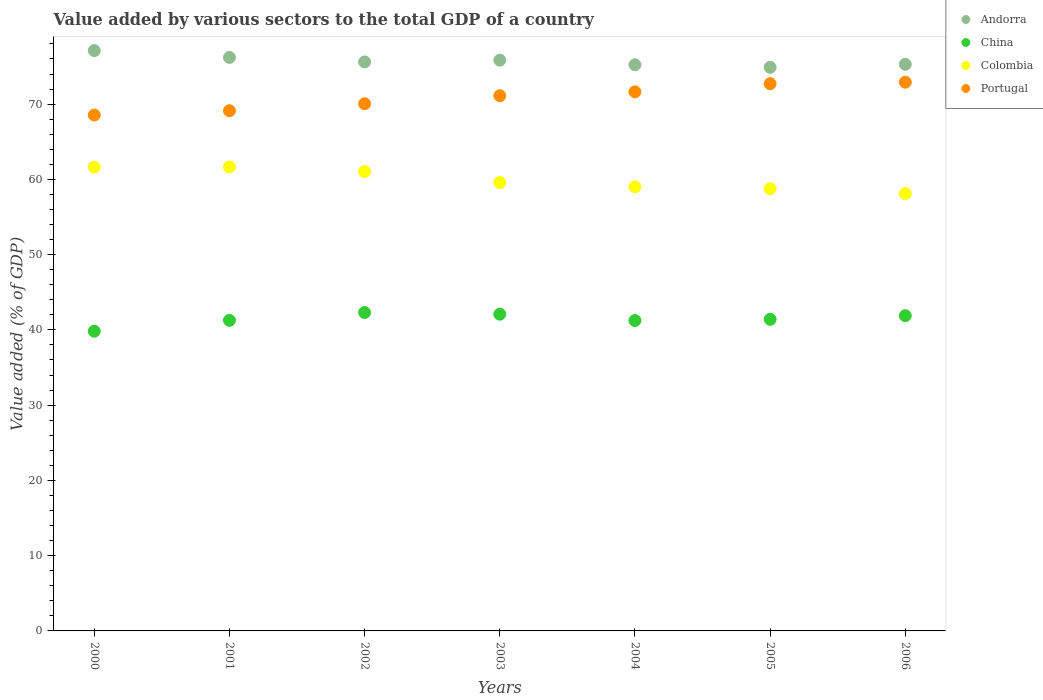Is the number of dotlines equal to the number of legend labels?
Give a very brief answer. Yes. What is the value added by various sectors to the total GDP in Portugal in 2001?
Give a very brief answer. 69.12. Across all years, what is the maximum value added by various sectors to the total GDP in Portugal?
Your answer should be very brief. 72.91. Across all years, what is the minimum value added by various sectors to the total GDP in Portugal?
Keep it short and to the point. 68.55. What is the total value added by various sectors to the total GDP in Portugal in the graph?
Provide a succinct answer. 496.09. What is the difference between the value added by various sectors to the total GDP in China in 2003 and that in 2006?
Ensure brevity in your answer.  0.2. What is the difference between the value added by various sectors to the total GDP in Colombia in 2003 and the value added by various sectors to the total GDP in Portugal in 2000?
Provide a succinct answer. -8.96. What is the average value added by various sectors to the total GDP in Portugal per year?
Make the answer very short. 70.87. In the year 2001, what is the difference between the value added by various sectors to the total GDP in Colombia and value added by various sectors to the total GDP in Andorra?
Make the answer very short. -14.54. What is the ratio of the value added by various sectors to the total GDP in Andorra in 2000 to that in 2005?
Offer a very short reply. 1.03. What is the difference between the highest and the second highest value added by various sectors to the total GDP in Andorra?
Provide a succinct answer. 0.91. What is the difference between the highest and the lowest value added by various sectors to the total GDP in Colombia?
Ensure brevity in your answer.  3.54. Is the sum of the value added by various sectors to the total GDP in Portugal in 2003 and 2004 greater than the maximum value added by various sectors to the total GDP in China across all years?
Provide a succinct answer. Yes. Is it the case that in every year, the sum of the value added by various sectors to the total GDP in Andorra and value added by various sectors to the total GDP in China  is greater than the value added by various sectors to the total GDP in Portugal?
Ensure brevity in your answer.  Yes. Does the value added by various sectors to the total GDP in Colombia monotonically increase over the years?
Provide a short and direct response. No. Are the values on the major ticks of Y-axis written in scientific E-notation?
Offer a very short reply. No. Does the graph contain grids?
Your answer should be compact. No. Where does the legend appear in the graph?
Ensure brevity in your answer.  Top right. What is the title of the graph?
Your answer should be compact. Value added by various sectors to the total GDP of a country. Does "Belarus" appear as one of the legend labels in the graph?
Provide a succinct answer. No. What is the label or title of the Y-axis?
Ensure brevity in your answer.  Value added (% of GDP). What is the Value added (% of GDP) of Andorra in 2000?
Offer a very short reply. 77.11. What is the Value added (% of GDP) in China in 2000?
Your answer should be very brief. 39.82. What is the Value added (% of GDP) of Colombia in 2000?
Offer a terse response. 61.63. What is the Value added (% of GDP) of Portugal in 2000?
Your response must be concise. 68.55. What is the Value added (% of GDP) of Andorra in 2001?
Your response must be concise. 76.21. What is the Value added (% of GDP) in China in 2001?
Provide a succinct answer. 41.27. What is the Value added (% of GDP) in Colombia in 2001?
Provide a succinct answer. 61.66. What is the Value added (% of GDP) in Portugal in 2001?
Your answer should be very brief. 69.12. What is the Value added (% of GDP) in Andorra in 2002?
Ensure brevity in your answer.  75.6. What is the Value added (% of GDP) in China in 2002?
Your response must be concise. 42.3. What is the Value added (% of GDP) of Colombia in 2002?
Ensure brevity in your answer.  61.04. What is the Value added (% of GDP) in Portugal in 2002?
Give a very brief answer. 70.05. What is the Value added (% of GDP) in Andorra in 2003?
Your response must be concise. 75.84. What is the Value added (% of GDP) of China in 2003?
Offer a terse response. 42.09. What is the Value added (% of GDP) of Colombia in 2003?
Keep it short and to the point. 59.59. What is the Value added (% of GDP) in Portugal in 2003?
Offer a very short reply. 71.11. What is the Value added (% of GDP) in Andorra in 2004?
Offer a very short reply. 75.23. What is the Value added (% of GDP) in China in 2004?
Provide a succinct answer. 41.24. What is the Value added (% of GDP) in Colombia in 2004?
Provide a short and direct response. 59. What is the Value added (% of GDP) in Portugal in 2004?
Your response must be concise. 71.63. What is the Value added (% of GDP) in Andorra in 2005?
Provide a succinct answer. 74.89. What is the Value added (% of GDP) in China in 2005?
Provide a succinct answer. 41.4. What is the Value added (% of GDP) in Colombia in 2005?
Your answer should be very brief. 58.77. What is the Value added (% of GDP) in Portugal in 2005?
Offer a terse response. 72.72. What is the Value added (% of GDP) in Andorra in 2006?
Provide a succinct answer. 75.29. What is the Value added (% of GDP) of China in 2006?
Ensure brevity in your answer.  41.89. What is the Value added (% of GDP) of Colombia in 2006?
Your answer should be compact. 58.12. What is the Value added (% of GDP) in Portugal in 2006?
Offer a very short reply. 72.91. Across all years, what is the maximum Value added (% of GDP) of Andorra?
Provide a succinct answer. 77.11. Across all years, what is the maximum Value added (% of GDP) of China?
Your answer should be compact. 42.3. Across all years, what is the maximum Value added (% of GDP) in Colombia?
Your answer should be compact. 61.66. Across all years, what is the maximum Value added (% of GDP) in Portugal?
Make the answer very short. 72.91. Across all years, what is the minimum Value added (% of GDP) in Andorra?
Provide a short and direct response. 74.89. Across all years, what is the minimum Value added (% of GDP) of China?
Provide a short and direct response. 39.82. Across all years, what is the minimum Value added (% of GDP) in Colombia?
Keep it short and to the point. 58.12. Across all years, what is the minimum Value added (% of GDP) of Portugal?
Give a very brief answer. 68.55. What is the total Value added (% of GDP) in Andorra in the graph?
Make the answer very short. 530.17. What is the total Value added (% of GDP) of China in the graph?
Ensure brevity in your answer.  290.02. What is the total Value added (% of GDP) in Colombia in the graph?
Your answer should be very brief. 419.8. What is the total Value added (% of GDP) in Portugal in the graph?
Offer a very short reply. 496.09. What is the difference between the Value added (% of GDP) of Andorra in 2000 and that in 2001?
Your answer should be compact. 0.91. What is the difference between the Value added (% of GDP) in China in 2000 and that in 2001?
Provide a succinct answer. -1.45. What is the difference between the Value added (% of GDP) of Colombia in 2000 and that in 2001?
Offer a terse response. -0.03. What is the difference between the Value added (% of GDP) in Portugal in 2000 and that in 2001?
Provide a succinct answer. -0.57. What is the difference between the Value added (% of GDP) of Andorra in 2000 and that in 2002?
Provide a succinct answer. 1.51. What is the difference between the Value added (% of GDP) in China in 2000 and that in 2002?
Keep it short and to the point. -2.48. What is the difference between the Value added (% of GDP) of Colombia in 2000 and that in 2002?
Your answer should be compact. 0.59. What is the difference between the Value added (% of GDP) of Portugal in 2000 and that in 2002?
Keep it short and to the point. -1.5. What is the difference between the Value added (% of GDP) of Andorra in 2000 and that in 2003?
Make the answer very short. 1.27. What is the difference between the Value added (% of GDP) of China in 2000 and that in 2003?
Ensure brevity in your answer.  -2.26. What is the difference between the Value added (% of GDP) of Colombia in 2000 and that in 2003?
Provide a succinct answer. 2.04. What is the difference between the Value added (% of GDP) in Portugal in 2000 and that in 2003?
Make the answer very short. -2.56. What is the difference between the Value added (% of GDP) in Andorra in 2000 and that in 2004?
Keep it short and to the point. 1.88. What is the difference between the Value added (% of GDP) of China in 2000 and that in 2004?
Your response must be concise. -1.42. What is the difference between the Value added (% of GDP) of Colombia in 2000 and that in 2004?
Your answer should be compact. 2.63. What is the difference between the Value added (% of GDP) in Portugal in 2000 and that in 2004?
Give a very brief answer. -3.08. What is the difference between the Value added (% of GDP) in Andorra in 2000 and that in 2005?
Offer a very short reply. 2.22. What is the difference between the Value added (% of GDP) in China in 2000 and that in 2005?
Offer a terse response. -1.58. What is the difference between the Value added (% of GDP) in Colombia in 2000 and that in 2005?
Offer a very short reply. 2.86. What is the difference between the Value added (% of GDP) in Portugal in 2000 and that in 2005?
Give a very brief answer. -4.17. What is the difference between the Value added (% of GDP) in Andorra in 2000 and that in 2006?
Ensure brevity in your answer.  1.82. What is the difference between the Value added (% of GDP) in China in 2000 and that in 2006?
Offer a very short reply. -2.07. What is the difference between the Value added (% of GDP) in Colombia in 2000 and that in 2006?
Give a very brief answer. 3.51. What is the difference between the Value added (% of GDP) in Portugal in 2000 and that in 2006?
Your response must be concise. -4.36. What is the difference between the Value added (% of GDP) in Andorra in 2001 and that in 2002?
Your answer should be very brief. 0.6. What is the difference between the Value added (% of GDP) of China in 2001 and that in 2002?
Provide a succinct answer. -1.04. What is the difference between the Value added (% of GDP) of Colombia in 2001 and that in 2002?
Make the answer very short. 0.62. What is the difference between the Value added (% of GDP) of Portugal in 2001 and that in 2002?
Provide a short and direct response. -0.93. What is the difference between the Value added (% of GDP) in Andorra in 2001 and that in 2003?
Your answer should be compact. 0.37. What is the difference between the Value added (% of GDP) in China in 2001 and that in 2003?
Offer a very short reply. -0.82. What is the difference between the Value added (% of GDP) in Colombia in 2001 and that in 2003?
Your answer should be compact. 2.07. What is the difference between the Value added (% of GDP) in Portugal in 2001 and that in 2003?
Your response must be concise. -1.99. What is the difference between the Value added (% of GDP) in China in 2001 and that in 2004?
Ensure brevity in your answer.  0.03. What is the difference between the Value added (% of GDP) of Colombia in 2001 and that in 2004?
Offer a terse response. 2.66. What is the difference between the Value added (% of GDP) in Portugal in 2001 and that in 2004?
Offer a terse response. -2.51. What is the difference between the Value added (% of GDP) of Andorra in 2001 and that in 2005?
Keep it short and to the point. 1.32. What is the difference between the Value added (% of GDP) in China in 2001 and that in 2005?
Your answer should be very brief. -0.13. What is the difference between the Value added (% of GDP) in Colombia in 2001 and that in 2005?
Your response must be concise. 2.9. What is the difference between the Value added (% of GDP) in Portugal in 2001 and that in 2005?
Keep it short and to the point. -3.6. What is the difference between the Value added (% of GDP) of Andorra in 2001 and that in 2006?
Your answer should be compact. 0.92. What is the difference between the Value added (% of GDP) in China in 2001 and that in 2006?
Provide a short and direct response. -0.62. What is the difference between the Value added (% of GDP) in Colombia in 2001 and that in 2006?
Ensure brevity in your answer.  3.54. What is the difference between the Value added (% of GDP) in Portugal in 2001 and that in 2006?
Ensure brevity in your answer.  -3.79. What is the difference between the Value added (% of GDP) of Andorra in 2002 and that in 2003?
Offer a very short reply. -0.23. What is the difference between the Value added (% of GDP) in China in 2002 and that in 2003?
Your answer should be compact. 0.22. What is the difference between the Value added (% of GDP) in Colombia in 2002 and that in 2003?
Offer a terse response. 1.45. What is the difference between the Value added (% of GDP) in Portugal in 2002 and that in 2003?
Keep it short and to the point. -1.06. What is the difference between the Value added (% of GDP) in Andorra in 2002 and that in 2004?
Ensure brevity in your answer.  0.38. What is the difference between the Value added (% of GDP) in China in 2002 and that in 2004?
Your response must be concise. 1.06. What is the difference between the Value added (% of GDP) of Colombia in 2002 and that in 2004?
Your answer should be compact. 2.04. What is the difference between the Value added (% of GDP) in Portugal in 2002 and that in 2004?
Your response must be concise. -1.58. What is the difference between the Value added (% of GDP) of Andorra in 2002 and that in 2005?
Make the answer very short. 0.72. What is the difference between the Value added (% of GDP) in China in 2002 and that in 2005?
Make the answer very short. 0.9. What is the difference between the Value added (% of GDP) in Colombia in 2002 and that in 2005?
Provide a short and direct response. 2.27. What is the difference between the Value added (% of GDP) of Portugal in 2002 and that in 2005?
Your answer should be compact. -2.67. What is the difference between the Value added (% of GDP) of Andorra in 2002 and that in 2006?
Your answer should be very brief. 0.32. What is the difference between the Value added (% of GDP) in China in 2002 and that in 2006?
Offer a very short reply. 0.41. What is the difference between the Value added (% of GDP) of Colombia in 2002 and that in 2006?
Your answer should be compact. 2.92. What is the difference between the Value added (% of GDP) in Portugal in 2002 and that in 2006?
Provide a short and direct response. -2.86. What is the difference between the Value added (% of GDP) in Andorra in 2003 and that in 2004?
Offer a terse response. 0.61. What is the difference between the Value added (% of GDP) of China in 2003 and that in 2004?
Provide a succinct answer. 0.84. What is the difference between the Value added (% of GDP) in Colombia in 2003 and that in 2004?
Your response must be concise. 0.59. What is the difference between the Value added (% of GDP) of Portugal in 2003 and that in 2004?
Offer a very short reply. -0.52. What is the difference between the Value added (% of GDP) of Andorra in 2003 and that in 2005?
Make the answer very short. 0.95. What is the difference between the Value added (% of GDP) of China in 2003 and that in 2005?
Ensure brevity in your answer.  0.68. What is the difference between the Value added (% of GDP) in Colombia in 2003 and that in 2005?
Ensure brevity in your answer.  0.82. What is the difference between the Value added (% of GDP) in Portugal in 2003 and that in 2005?
Provide a succinct answer. -1.6. What is the difference between the Value added (% of GDP) in Andorra in 2003 and that in 2006?
Keep it short and to the point. 0.55. What is the difference between the Value added (% of GDP) in China in 2003 and that in 2006?
Make the answer very short. 0.2. What is the difference between the Value added (% of GDP) of Colombia in 2003 and that in 2006?
Ensure brevity in your answer.  1.47. What is the difference between the Value added (% of GDP) of Portugal in 2003 and that in 2006?
Give a very brief answer. -1.8. What is the difference between the Value added (% of GDP) in Andorra in 2004 and that in 2005?
Your response must be concise. 0.34. What is the difference between the Value added (% of GDP) in China in 2004 and that in 2005?
Make the answer very short. -0.16. What is the difference between the Value added (% of GDP) in Colombia in 2004 and that in 2005?
Your response must be concise. 0.23. What is the difference between the Value added (% of GDP) of Portugal in 2004 and that in 2005?
Your answer should be compact. -1.09. What is the difference between the Value added (% of GDP) of Andorra in 2004 and that in 2006?
Your answer should be compact. -0.06. What is the difference between the Value added (% of GDP) in China in 2004 and that in 2006?
Offer a terse response. -0.65. What is the difference between the Value added (% of GDP) in Colombia in 2004 and that in 2006?
Your response must be concise. 0.88. What is the difference between the Value added (% of GDP) in Portugal in 2004 and that in 2006?
Offer a very short reply. -1.28. What is the difference between the Value added (% of GDP) in Andorra in 2005 and that in 2006?
Make the answer very short. -0.4. What is the difference between the Value added (% of GDP) of China in 2005 and that in 2006?
Keep it short and to the point. -0.49. What is the difference between the Value added (% of GDP) in Colombia in 2005 and that in 2006?
Provide a succinct answer. 0.65. What is the difference between the Value added (% of GDP) of Portugal in 2005 and that in 2006?
Provide a short and direct response. -0.2. What is the difference between the Value added (% of GDP) in Andorra in 2000 and the Value added (% of GDP) in China in 2001?
Give a very brief answer. 35.84. What is the difference between the Value added (% of GDP) in Andorra in 2000 and the Value added (% of GDP) in Colombia in 2001?
Make the answer very short. 15.45. What is the difference between the Value added (% of GDP) of Andorra in 2000 and the Value added (% of GDP) of Portugal in 2001?
Give a very brief answer. 7.99. What is the difference between the Value added (% of GDP) in China in 2000 and the Value added (% of GDP) in Colombia in 2001?
Your response must be concise. -21.84. What is the difference between the Value added (% of GDP) in China in 2000 and the Value added (% of GDP) in Portugal in 2001?
Ensure brevity in your answer.  -29.3. What is the difference between the Value added (% of GDP) of Colombia in 2000 and the Value added (% of GDP) of Portugal in 2001?
Provide a short and direct response. -7.49. What is the difference between the Value added (% of GDP) of Andorra in 2000 and the Value added (% of GDP) of China in 2002?
Provide a succinct answer. 34.81. What is the difference between the Value added (% of GDP) of Andorra in 2000 and the Value added (% of GDP) of Colombia in 2002?
Keep it short and to the point. 16.07. What is the difference between the Value added (% of GDP) in Andorra in 2000 and the Value added (% of GDP) in Portugal in 2002?
Your answer should be compact. 7.06. What is the difference between the Value added (% of GDP) in China in 2000 and the Value added (% of GDP) in Colombia in 2002?
Provide a succinct answer. -21.21. What is the difference between the Value added (% of GDP) in China in 2000 and the Value added (% of GDP) in Portugal in 2002?
Give a very brief answer. -30.23. What is the difference between the Value added (% of GDP) in Colombia in 2000 and the Value added (% of GDP) in Portugal in 2002?
Provide a short and direct response. -8.42. What is the difference between the Value added (% of GDP) of Andorra in 2000 and the Value added (% of GDP) of China in 2003?
Offer a terse response. 35.02. What is the difference between the Value added (% of GDP) of Andorra in 2000 and the Value added (% of GDP) of Colombia in 2003?
Ensure brevity in your answer.  17.52. What is the difference between the Value added (% of GDP) in Andorra in 2000 and the Value added (% of GDP) in Portugal in 2003?
Make the answer very short. 6. What is the difference between the Value added (% of GDP) of China in 2000 and the Value added (% of GDP) of Colombia in 2003?
Offer a terse response. -19.77. What is the difference between the Value added (% of GDP) of China in 2000 and the Value added (% of GDP) of Portugal in 2003?
Keep it short and to the point. -31.29. What is the difference between the Value added (% of GDP) in Colombia in 2000 and the Value added (% of GDP) in Portugal in 2003?
Make the answer very short. -9.49. What is the difference between the Value added (% of GDP) in Andorra in 2000 and the Value added (% of GDP) in China in 2004?
Provide a short and direct response. 35.87. What is the difference between the Value added (% of GDP) of Andorra in 2000 and the Value added (% of GDP) of Colombia in 2004?
Provide a succinct answer. 18.11. What is the difference between the Value added (% of GDP) in Andorra in 2000 and the Value added (% of GDP) in Portugal in 2004?
Offer a very short reply. 5.48. What is the difference between the Value added (% of GDP) of China in 2000 and the Value added (% of GDP) of Colombia in 2004?
Make the answer very short. -19.17. What is the difference between the Value added (% of GDP) in China in 2000 and the Value added (% of GDP) in Portugal in 2004?
Make the answer very short. -31.81. What is the difference between the Value added (% of GDP) of Colombia in 2000 and the Value added (% of GDP) of Portugal in 2004?
Keep it short and to the point. -10. What is the difference between the Value added (% of GDP) of Andorra in 2000 and the Value added (% of GDP) of China in 2005?
Ensure brevity in your answer.  35.71. What is the difference between the Value added (% of GDP) of Andorra in 2000 and the Value added (% of GDP) of Colombia in 2005?
Your answer should be compact. 18.34. What is the difference between the Value added (% of GDP) in Andorra in 2000 and the Value added (% of GDP) in Portugal in 2005?
Your answer should be compact. 4.39. What is the difference between the Value added (% of GDP) of China in 2000 and the Value added (% of GDP) of Colombia in 2005?
Offer a terse response. -18.94. What is the difference between the Value added (% of GDP) of China in 2000 and the Value added (% of GDP) of Portugal in 2005?
Provide a succinct answer. -32.89. What is the difference between the Value added (% of GDP) of Colombia in 2000 and the Value added (% of GDP) of Portugal in 2005?
Offer a terse response. -11.09. What is the difference between the Value added (% of GDP) in Andorra in 2000 and the Value added (% of GDP) in China in 2006?
Your answer should be compact. 35.22. What is the difference between the Value added (% of GDP) of Andorra in 2000 and the Value added (% of GDP) of Colombia in 2006?
Ensure brevity in your answer.  18.99. What is the difference between the Value added (% of GDP) of Andorra in 2000 and the Value added (% of GDP) of Portugal in 2006?
Make the answer very short. 4.2. What is the difference between the Value added (% of GDP) in China in 2000 and the Value added (% of GDP) in Colombia in 2006?
Your answer should be very brief. -18.29. What is the difference between the Value added (% of GDP) in China in 2000 and the Value added (% of GDP) in Portugal in 2006?
Provide a short and direct response. -33.09. What is the difference between the Value added (% of GDP) of Colombia in 2000 and the Value added (% of GDP) of Portugal in 2006?
Make the answer very short. -11.28. What is the difference between the Value added (% of GDP) of Andorra in 2001 and the Value added (% of GDP) of China in 2002?
Your answer should be very brief. 33.9. What is the difference between the Value added (% of GDP) of Andorra in 2001 and the Value added (% of GDP) of Colombia in 2002?
Offer a terse response. 15.17. What is the difference between the Value added (% of GDP) in Andorra in 2001 and the Value added (% of GDP) in Portugal in 2002?
Keep it short and to the point. 6.15. What is the difference between the Value added (% of GDP) in China in 2001 and the Value added (% of GDP) in Colombia in 2002?
Your answer should be compact. -19.77. What is the difference between the Value added (% of GDP) in China in 2001 and the Value added (% of GDP) in Portugal in 2002?
Ensure brevity in your answer.  -28.78. What is the difference between the Value added (% of GDP) of Colombia in 2001 and the Value added (% of GDP) of Portugal in 2002?
Provide a short and direct response. -8.39. What is the difference between the Value added (% of GDP) in Andorra in 2001 and the Value added (% of GDP) in China in 2003?
Give a very brief answer. 34.12. What is the difference between the Value added (% of GDP) of Andorra in 2001 and the Value added (% of GDP) of Colombia in 2003?
Provide a succinct answer. 16.62. What is the difference between the Value added (% of GDP) in Andorra in 2001 and the Value added (% of GDP) in Portugal in 2003?
Provide a succinct answer. 5.09. What is the difference between the Value added (% of GDP) in China in 2001 and the Value added (% of GDP) in Colombia in 2003?
Your answer should be very brief. -18.32. What is the difference between the Value added (% of GDP) in China in 2001 and the Value added (% of GDP) in Portugal in 2003?
Offer a very short reply. -29.84. What is the difference between the Value added (% of GDP) in Colombia in 2001 and the Value added (% of GDP) in Portugal in 2003?
Your response must be concise. -9.45. What is the difference between the Value added (% of GDP) of Andorra in 2001 and the Value added (% of GDP) of China in 2004?
Offer a very short reply. 34.96. What is the difference between the Value added (% of GDP) in Andorra in 2001 and the Value added (% of GDP) in Colombia in 2004?
Keep it short and to the point. 17.21. What is the difference between the Value added (% of GDP) in Andorra in 2001 and the Value added (% of GDP) in Portugal in 2004?
Offer a very short reply. 4.57. What is the difference between the Value added (% of GDP) of China in 2001 and the Value added (% of GDP) of Colombia in 2004?
Provide a succinct answer. -17.73. What is the difference between the Value added (% of GDP) in China in 2001 and the Value added (% of GDP) in Portugal in 2004?
Your answer should be very brief. -30.36. What is the difference between the Value added (% of GDP) of Colombia in 2001 and the Value added (% of GDP) of Portugal in 2004?
Ensure brevity in your answer.  -9.97. What is the difference between the Value added (% of GDP) in Andorra in 2001 and the Value added (% of GDP) in China in 2005?
Your response must be concise. 34.8. What is the difference between the Value added (% of GDP) of Andorra in 2001 and the Value added (% of GDP) of Colombia in 2005?
Keep it short and to the point. 17.44. What is the difference between the Value added (% of GDP) of Andorra in 2001 and the Value added (% of GDP) of Portugal in 2005?
Make the answer very short. 3.49. What is the difference between the Value added (% of GDP) in China in 2001 and the Value added (% of GDP) in Colombia in 2005?
Make the answer very short. -17.5. What is the difference between the Value added (% of GDP) of China in 2001 and the Value added (% of GDP) of Portugal in 2005?
Offer a terse response. -31.45. What is the difference between the Value added (% of GDP) in Colombia in 2001 and the Value added (% of GDP) in Portugal in 2005?
Ensure brevity in your answer.  -11.06. What is the difference between the Value added (% of GDP) in Andorra in 2001 and the Value added (% of GDP) in China in 2006?
Ensure brevity in your answer.  34.31. What is the difference between the Value added (% of GDP) in Andorra in 2001 and the Value added (% of GDP) in Colombia in 2006?
Provide a succinct answer. 18.09. What is the difference between the Value added (% of GDP) in Andorra in 2001 and the Value added (% of GDP) in Portugal in 2006?
Your answer should be compact. 3.29. What is the difference between the Value added (% of GDP) of China in 2001 and the Value added (% of GDP) of Colombia in 2006?
Offer a terse response. -16.85. What is the difference between the Value added (% of GDP) in China in 2001 and the Value added (% of GDP) in Portugal in 2006?
Make the answer very short. -31.64. What is the difference between the Value added (% of GDP) in Colombia in 2001 and the Value added (% of GDP) in Portugal in 2006?
Offer a very short reply. -11.25. What is the difference between the Value added (% of GDP) in Andorra in 2002 and the Value added (% of GDP) in China in 2003?
Ensure brevity in your answer.  33.52. What is the difference between the Value added (% of GDP) in Andorra in 2002 and the Value added (% of GDP) in Colombia in 2003?
Offer a terse response. 16.02. What is the difference between the Value added (% of GDP) in Andorra in 2002 and the Value added (% of GDP) in Portugal in 2003?
Give a very brief answer. 4.49. What is the difference between the Value added (% of GDP) in China in 2002 and the Value added (% of GDP) in Colombia in 2003?
Offer a very short reply. -17.29. What is the difference between the Value added (% of GDP) of China in 2002 and the Value added (% of GDP) of Portugal in 2003?
Provide a succinct answer. -28.81. What is the difference between the Value added (% of GDP) of Colombia in 2002 and the Value added (% of GDP) of Portugal in 2003?
Provide a succinct answer. -10.08. What is the difference between the Value added (% of GDP) of Andorra in 2002 and the Value added (% of GDP) of China in 2004?
Give a very brief answer. 34.36. What is the difference between the Value added (% of GDP) of Andorra in 2002 and the Value added (% of GDP) of Colombia in 2004?
Offer a very short reply. 16.61. What is the difference between the Value added (% of GDP) of Andorra in 2002 and the Value added (% of GDP) of Portugal in 2004?
Provide a short and direct response. 3.97. What is the difference between the Value added (% of GDP) in China in 2002 and the Value added (% of GDP) in Colombia in 2004?
Your response must be concise. -16.69. What is the difference between the Value added (% of GDP) of China in 2002 and the Value added (% of GDP) of Portugal in 2004?
Your response must be concise. -29.33. What is the difference between the Value added (% of GDP) in Colombia in 2002 and the Value added (% of GDP) in Portugal in 2004?
Ensure brevity in your answer.  -10.59. What is the difference between the Value added (% of GDP) of Andorra in 2002 and the Value added (% of GDP) of China in 2005?
Provide a short and direct response. 34.2. What is the difference between the Value added (% of GDP) of Andorra in 2002 and the Value added (% of GDP) of Colombia in 2005?
Your response must be concise. 16.84. What is the difference between the Value added (% of GDP) in Andorra in 2002 and the Value added (% of GDP) in Portugal in 2005?
Keep it short and to the point. 2.89. What is the difference between the Value added (% of GDP) in China in 2002 and the Value added (% of GDP) in Colombia in 2005?
Your response must be concise. -16.46. What is the difference between the Value added (% of GDP) in China in 2002 and the Value added (% of GDP) in Portugal in 2005?
Ensure brevity in your answer.  -30.41. What is the difference between the Value added (% of GDP) in Colombia in 2002 and the Value added (% of GDP) in Portugal in 2005?
Your answer should be very brief. -11.68. What is the difference between the Value added (% of GDP) in Andorra in 2002 and the Value added (% of GDP) in China in 2006?
Provide a short and direct response. 33.71. What is the difference between the Value added (% of GDP) in Andorra in 2002 and the Value added (% of GDP) in Colombia in 2006?
Make the answer very short. 17.49. What is the difference between the Value added (% of GDP) in Andorra in 2002 and the Value added (% of GDP) in Portugal in 2006?
Provide a succinct answer. 2.69. What is the difference between the Value added (% of GDP) of China in 2002 and the Value added (% of GDP) of Colombia in 2006?
Offer a terse response. -15.81. What is the difference between the Value added (% of GDP) in China in 2002 and the Value added (% of GDP) in Portugal in 2006?
Your answer should be compact. -30.61. What is the difference between the Value added (% of GDP) in Colombia in 2002 and the Value added (% of GDP) in Portugal in 2006?
Offer a very short reply. -11.87. What is the difference between the Value added (% of GDP) of Andorra in 2003 and the Value added (% of GDP) of China in 2004?
Provide a short and direct response. 34.59. What is the difference between the Value added (% of GDP) of Andorra in 2003 and the Value added (% of GDP) of Colombia in 2004?
Offer a very short reply. 16.84. What is the difference between the Value added (% of GDP) of Andorra in 2003 and the Value added (% of GDP) of Portugal in 2004?
Ensure brevity in your answer.  4.21. What is the difference between the Value added (% of GDP) in China in 2003 and the Value added (% of GDP) in Colombia in 2004?
Ensure brevity in your answer.  -16.91. What is the difference between the Value added (% of GDP) of China in 2003 and the Value added (% of GDP) of Portugal in 2004?
Offer a terse response. -29.54. What is the difference between the Value added (% of GDP) in Colombia in 2003 and the Value added (% of GDP) in Portugal in 2004?
Ensure brevity in your answer.  -12.04. What is the difference between the Value added (% of GDP) in Andorra in 2003 and the Value added (% of GDP) in China in 2005?
Your answer should be very brief. 34.43. What is the difference between the Value added (% of GDP) in Andorra in 2003 and the Value added (% of GDP) in Colombia in 2005?
Provide a succinct answer. 17.07. What is the difference between the Value added (% of GDP) in Andorra in 2003 and the Value added (% of GDP) in Portugal in 2005?
Give a very brief answer. 3.12. What is the difference between the Value added (% of GDP) of China in 2003 and the Value added (% of GDP) of Colombia in 2005?
Keep it short and to the point. -16.68. What is the difference between the Value added (% of GDP) of China in 2003 and the Value added (% of GDP) of Portugal in 2005?
Offer a very short reply. -30.63. What is the difference between the Value added (% of GDP) of Colombia in 2003 and the Value added (% of GDP) of Portugal in 2005?
Your response must be concise. -13.13. What is the difference between the Value added (% of GDP) of Andorra in 2003 and the Value added (% of GDP) of China in 2006?
Keep it short and to the point. 33.94. What is the difference between the Value added (% of GDP) of Andorra in 2003 and the Value added (% of GDP) of Colombia in 2006?
Ensure brevity in your answer.  17.72. What is the difference between the Value added (% of GDP) in Andorra in 2003 and the Value added (% of GDP) in Portugal in 2006?
Offer a very short reply. 2.92. What is the difference between the Value added (% of GDP) in China in 2003 and the Value added (% of GDP) in Colombia in 2006?
Provide a succinct answer. -16.03. What is the difference between the Value added (% of GDP) of China in 2003 and the Value added (% of GDP) of Portugal in 2006?
Offer a terse response. -30.83. What is the difference between the Value added (% of GDP) in Colombia in 2003 and the Value added (% of GDP) in Portugal in 2006?
Your answer should be very brief. -13.32. What is the difference between the Value added (% of GDP) in Andorra in 2004 and the Value added (% of GDP) in China in 2005?
Offer a very short reply. 33.83. What is the difference between the Value added (% of GDP) of Andorra in 2004 and the Value added (% of GDP) of Colombia in 2005?
Offer a very short reply. 16.46. What is the difference between the Value added (% of GDP) of Andorra in 2004 and the Value added (% of GDP) of Portugal in 2005?
Make the answer very short. 2.51. What is the difference between the Value added (% of GDP) in China in 2004 and the Value added (% of GDP) in Colombia in 2005?
Give a very brief answer. -17.52. What is the difference between the Value added (% of GDP) in China in 2004 and the Value added (% of GDP) in Portugal in 2005?
Ensure brevity in your answer.  -31.47. What is the difference between the Value added (% of GDP) of Colombia in 2004 and the Value added (% of GDP) of Portugal in 2005?
Offer a terse response. -13.72. What is the difference between the Value added (% of GDP) of Andorra in 2004 and the Value added (% of GDP) of China in 2006?
Ensure brevity in your answer.  33.34. What is the difference between the Value added (% of GDP) in Andorra in 2004 and the Value added (% of GDP) in Colombia in 2006?
Your response must be concise. 17.11. What is the difference between the Value added (% of GDP) in Andorra in 2004 and the Value added (% of GDP) in Portugal in 2006?
Keep it short and to the point. 2.32. What is the difference between the Value added (% of GDP) of China in 2004 and the Value added (% of GDP) of Colombia in 2006?
Offer a terse response. -16.88. What is the difference between the Value added (% of GDP) in China in 2004 and the Value added (% of GDP) in Portugal in 2006?
Ensure brevity in your answer.  -31.67. What is the difference between the Value added (% of GDP) of Colombia in 2004 and the Value added (% of GDP) of Portugal in 2006?
Offer a very short reply. -13.92. What is the difference between the Value added (% of GDP) of Andorra in 2005 and the Value added (% of GDP) of China in 2006?
Provide a succinct answer. 33. What is the difference between the Value added (% of GDP) of Andorra in 2005 and the Value added (% of GDP) of Colombia in 2006?
Your response must be concise. 16.77. What is the difference between the Value added (% of GDP) in Andorra in 2005 and the Value added (% of GDP) in Portugal in 2006?
Offer a very short reply. 1.98. What is the difference between the Value added (% of GDP) in China in 2005 and the Value added (% of GDP) in Colombia in 2006?
Your answer should be very brief. -16.72. What is the difference between the Value added (% of GDP) of China in 2005 and the Value added (% of GDP) of Portugal in 2006?
Your response must be concise. -31.51. What is the difference between the Value added (% of GDP) in Colombia in 2005 and the Value added (% of GDP) in Portugal in 2006?
Offer a very short reply. -14.15. What is the average Value added (% of GDP) of Andorra per year?
Your answer should be compact. 75.74. What is the average Value added (% of GDP) in China per year?
Make the answer very short. 41.43. What is the average Value added (% of GDP) of Colombia per year?
Provide a succinct answer. 59.97. What is the average Value added (% of GDP) in Portugal per year?
Your response must be concise. 70.87. In the year 2000, what is the difference between the Value added (% of GDP) of Andorra and Value added (% of GDP) of China?
Ensure brevity in your answer.  37.29. In the year 2000, what is the difference between the Value added (% of GDP) in Andorra and Value added (% of GDP) in Colombia?
Ensure brevity in your answer.  15.48. In the year 2000, what is the difference between the Value added (% of GDP) in Andorra and Value added (% of GDP) in Portugal?
Your answer should be compact. 8.56. In the year 2000, what is the difference between the Value added (% of GDP) in China and Value added (% of GDP) in Colombia?
Make the answer very short. -21.8. In the year 2000, what is the difference between the Value added (% of GDP) of China and Value added (% of GDP) of Portugal?
Your response must be concise. -28.73. In the year 2000, what is the difference between the Value added (% of GDP) in Colombia and Value added (% of GDP) in Portugal?
Provide a short and direct response. -6.92. In the year 2001, what is the difference between the Value added (% of GDP) of Andorra and Value added (% of GDP) of China?
Give a very brief answer. 34.94. In the year 2001, what is the difference between the Value added (% of GDP) in Andorra and Value added (% of GDP) in Colombia?
Offer a terse response. 14.54. In the year 2001, what is the difference between the Value added (% of GDP) in Andorra and Value added (% of GDP) in Portugal?
Your response must be concise. 7.09. In the year 2001, what is the difference between the Value added (% of GDP) of China and Value added (% of GDP) of Colombia?
Provide a short and direct response. -20.39. In the year 2001, what is the difference between the Value added (% of GDP) of China and Value added (% of GDP) of Portugal?
Make the answer very short. -27.85. In the year 2001, what is the difference between the Value added (% of GDP) of Colombia and Value added (% of GDP) of Portugal?
Make the answer very short. -7.46. In the year 2002, what is the difference between the Value added (% of GDP) in Andorra and Value added (% of GDP) in China?
Make the answer very short. 33.3. In the year 2002, what is the difference between the Value added (% of GDP) in Andorra and Value added (% of GDP) in Colombia?
Give a very brief answer. 14.57. In the year 2002, what is the difference between the Value added (% of GDP) in Andorra and Value added (% of GDP) in Portugal?
Keep it short and to the point. 5.55. In the year 2002, what is the difference between the Value added (% of GDP) of China and Value added (% of GDP) of Colombia?
Offer a very short reply. -18.73. In the year 2002, what is the difference between the Value added (% of GDP) of China and Value added (% of GDP) of Portugal?
Ensure brevity in your answer.  -27.75. In the year 2002, what is the difference between the Value added (% of GDP) in Colombia and Value added (% of GDP) in Portugal?
Your answer should be compact. -9.01. In the year 2003, what is the difference between the Value added (% of GDP) of Andorra and Value added (% of GDP) of China?
Your answer should be compact. 33.75. In the year 2003, what is the difference between the Value added (% of GDP) of Andorra and Value added (% of GDP) of Colombia?
Give a very brief answer. 16.25. In the year 2003, what is the difference between the Value added (% of GDP) of Andorra and Value added (% of GDP) of Portugal?
Offer a very short reply. 4.72. In the year 2003, what is the difference between the Value added (% of GDP) in China and Value added (% of GDP) in Colombia?
Make the answer very short. -17.5. In the year 2003, what is the difference between the Value added (% of GDP) in China and Value added (% of GDP) in Portugal?
Provide a short and direct response. -29.03. In the year 2003, what is the difference between the Value added (% of GDP) of Colombia and Value added (% of GDP) of Portugal?
Your response must be concise. -11.52. In the year 2004, what is the difference between the Value added (% of GDP) of Andorra and Value added (% of GDP) of China?
Make the answer very short. 33.99. In the year 2004, what is the difference between the Value added (% of GDP) in Andorra and Value added (% of GDP) in Colombia?
Provide a succinct answer. 16.23. In the year 2004, what is the difference between the Value added (% of GDP) in Andorra and Value added (% of GDP) in Portugal?
Your answer should be compact. 3.6. In the year 2004, what is the difference between the Value added (% of GDP) in China and Value added (% of GDP) in Colombia?
Make the answer very short. -17.75. In the year 2004, what is the difference between the Value added (% of GDP) of China and Value added (% of GDP) of Portugal?
Your response must be concise. -30.39. In the year 2004, what is the difference between the Value added (% of GDP) of Colombia and Value added (% of GDP) of Portugal?
Provide a short and direct response. -12.63. In the year 2005, what is the difference between the Value added (% of GDP) in Andorra and Value added (% of GDP) in China?
Offer a very short reply. 33.49. In the year 2005, what is the difference between the Value added (% of GDP) in Andorra and Value added (% of GDP) in Colombia?
Your answer should be very brief. 16.12. In the year 2005, what is the difference between the Value added (% of GDP) in Andorra and Value added (% of GDP) in Portugal?
Your response must be concise. 2.17. In the year 2005, what is the difference between the Value added (% of GDP) in China and Value added (% of GDP) in Colombia?
Your response must be concise. -17.36. In the year 2005, what is the difference between the Value added (% of GDP) in China and Value added (% of GDP) in Portugal?
Your answer should be compact. -31.31. In the year 2005, what is the difference between the Value added (% of GDP) in Colombia and Value added (% of GDP) in Portugal?
Your answer should be compact. -13.95. In the year 2006, what is the difference between the Value added (% of GDP) in Andorra and Value added (% of GDP) in China?
Provide a short and direct response. 33.4. In the year 2006, what is the difference between the Value added (% of GDP) in Andorra and Value added (% of GDP) in Colombia?
Your response must be concise. 17.17. In the year 2006, what is the difference between the Value added (% of GDP) of Andorra and Value added (% of GDP) of Portugal?
Provide a short and direct response. 2.38. In the year 2006, what is the difference between the Value added (% of GDP) of China and Value added (% of GDP) of Colombia?
Keep it short and to the point. -16.23. In the year 2006, what is the difference between the Value added (% of GDP) of China and Value added (% of GDP) of Portugal?
Give a very brief answer. -31.02. In the year 2006, what is the difference between the Value added (% of GDP) in Colombia and Value added (% of GDP) in Portugal?
Provide a succinct answer. -14.79. What is the ratio of the Value added (% of GDP) of Andorra in 2000 to that in 2001?
Your answer should be very brief. 1.01. What is the ratio of the Value added (% of GDP) of Andorra in 2000 to that in 2002?
Ensure brevity in your answer.  1.02. What is the ratio of the Value added (% of GDP) of China in 2000 to that in 2002?
Your response must be concise. 0.94. What is the ratio of the Value added (% of GDP) in Colombia in 2000 to that in 2002?
Offer a terse response. 1.01. What is the ratio of the Value added (% of GDP) of Portugal in 2000 to that in 2002?
Keep it short and to the point. 0.98. What is the ratio of the Value added (% of GDP) of Andorra in 2000 to that in 2003?
Your answer should be very brief. 1.02. What is the ratio of the Value added (% of GDP) in China in 2000 to that in 2003?
Your answer should be compact. 0.95. What is the ratio of the Value added (% of GDP) in Colombia in 2000 to that in 2003?
Your answer should be very brief. 1.03. What is the ratio of the Value added (% of GDP) in Andorra in 2000 to that in 2004?
Give a very brief answer. 1.02. What is the ratio of the Value added (% of GDP) in China in 2000 to that in 2004?
Ensure brevity in your answer.  0.97. What is the ratio of the Value added (% of GDP) in Colombia in 2000 to that in 2004?
Ensure brevity in your answer.  1.04. What is the ratio of the Value added (% of GDP) of Andorra in 2000 to that in 2005?
Make the answer very short. 1.03. What is the ratio of the Value added (% of GDP) in China in 2000 to that in 2005?
Provide a succinct answer. 0.96. What is the ratio of the Value added (% of GDP) of Colombia in 2000 to that in 2005?
Offer a terse response. 1.05. What is the ratio of the Value added (% of GDP) of Portugal in 2000 to that in 2005?
Your response must be concise. 0.94. What is the ratio of the Value added (% of GDP) in Andorra in 2000 to that in 2006?
Offer a very short reply. 1.02. What is the ratio of the Value added (% of GDP) in China in 2000 to that in 2006?
Offer a very short reply. 0.95. What is the ratio of the Value added (% of GDP) in Colombia in 2000 to that in 2006?
Offer a terse response. 1.06. What is the ratio of the Value added (% of GDP) of Portugal in 2000 to that in 2006?
Ensure brevity in your answer.  0.94. What is the ratio of the Value added (% of GDP) of Andorra in 2001 to that in 2002?
Your response must be concise. 1.01. What is the ratio of the Value added (% of GDP) of China in 2001 to that in 2002?
Make the answer very short. 0.98. What is the ratio of the Value added (% of GDP) of Colombia in 2001 to that in 2002?
Ensure brevity in your answer.  1.01. What is the ratio of the Value added (% of GDP) in Portugal in 2001 to that in 2002?
Your response must be concise. 0.99. What is the ratio of the Value added (% of GDP) in China in 2001 to that in 2003?
Keep it short and to the point. 0.98. What is the ratio of the Value added (% of GDP) in Colombia in 2001 to that in 2003?
Offer a terse response. 1.03. What is the ratio of the Value added (% of GDP) in Andorra in 2001 to that in 2004?
Offer a terse response. 1.01. What is the ratio of the Value added (% of GDP) of China in 2001 to that in 2004?
Your answer should be very brief. 1. What is the ratio of the Value added (% of GDP) of Colombia in 2001 to that in 2004?
Provide a succinct answer. 1.05. What is the ratio of the Value added (% of GDP) in Portugal in 2001 to that in 2004?
Provide a short and direct response. 0.96. What is the ratio of the Value added (% of GDP) of Andorra in 2001 to that in 2005?
Provide a short and direct response. 1.02. What is the ratio of the Value added (% of GDP) in Colombia in 2001 to that in 2005?
Offer a very short reply. 1.05. What is the ratio of the Value added (% of GDP) of Portugal in 2001 to that in 2005?
Keep it short and to the point. 0.95. What is the ratio of the Value added (% of GDP) in Andorra in 2001 to that in 2006?
Provide a succinct answer. 1.01. What is the ratio of the Value added (% of GDP) in China in 2001 to that in 2006?
Give a very brief answer. 0.99. What is the ratio of the Value added (% of GDP) of Colombia in 2001 to that in 2006?
Provide a succinct answer. 1.06. What is the ratio of the Value added (% of GDP) in Portugal in 2001 to that in 2006?
Make the answer very short. 0.95. What is the ratio of the Value added (% of GDP) of Andorra in 2002 to that in 2003?
Provide a succinct answer. 1. What is the ratio of the Value added (% of GDP) of China in 2002 to that in 2003?
Your response must be concise. 1.01. What is the ratio of the Value added (% of GDP) in Colombia in 2002 to that in 2003?
Your answer should be very brief. 1.02. What is the ratio of the Value added (% of GDP) of Portugal in 2002 to that in 2003?
Your answer should be compact. 0.99. What is the ratio of the Value added (% of GDP) of China in 2002 to that in 2004?
Ensure brevity in your answer.  1.03. What is the ratio of the Value added (% of GDP) in Colombia in 2002 to that in 2004?
Your answer should be compact. 1.03. What is the ratio of the Value added (% of GDP) in Portugal in 2002 to that in 2004?
Keep it short and to the point. 0.98. What is the ratio of the Value added (% of GDP) in Andorra in 2002 to that in 2005?
Provide a succinct answer. 1.01. What is the ratio of the Value added (% of GDP) of China in 2002 to that in 2005?
Keep it short and to the point. 1.02. What is the ratio of the Value added (% of GDP) in Colombia in 2002 to that in 2005?
Give a very brief answer. 1.04. What is the ratio of the Value added (% of GDP) of Portugal in 2002 to that in 2005?
Your answer should be very brief. 0.96. What is the ratio of the Value added (% of GDP) in China in 2002 to that in 2006?
Give a very brief answer. 1.01. What is the ratio of the Value added (% of GDP) of Colombia in 2002 to that in 2006?
Make the answer very short. 1.05. What is the ratio of the Value added (% of GDP) of Portugal in 2002 to that in 2006?
Offer a terse response. 0.96. What is the ratio of the Value added (% of GDP) of China in 2003 to that in 2004?
Keep it short and to the point. 1.02. What is the ratio of the Value added (% of GDP) in Portugal in 2003 to that in 2004?
Ensure brevity in your answer.  0.99. What is the ratio of the Value added (% of GDP) of Andorra in 2003 to that in 2005?
Your response must be concise. 1.01. What is the ratio of the Value added (% of GDP) of China in 2003 to that in 2005?
Provide a short and direct response. 1.02. What is the ratio of the Value added (% of GDP) of Colombia in 2003 to that in 2005?
Ensure brevity in your answer.  1.01. What is the ratio of the Value added (% of GDP) of Portugal in 2003 to that in 2005?
Provide a short and direct response. 0.98. What is the ratio of the Value added (% of GDP) of Andorra in 2003 to that in 2006?
Your answer should be compact. 1.01. What is the ratio of the Value added (% of GDP) of Colombia in 2003 to that in 2006?
Provide a succinct answer. 1.03. What is the ratio of the Value added (% of GDP) of Portugal in 2003 to that in 2006?
Your response must be concise. 0.98. What is the ratio of the Value added (% of GDP) in Colombia in 2004 to that in 2005?
Provide a short and direct response. 1. What is the ratio of the Value added (% of GDP) in Portugal in 2004 to that in 2005?
Ensure brevity in your answer.  0.99. What is the ratio of the Value added (% of GDP) in China in 2004 to that in 2006?
Make the answer very short. 0.98. What is the ratio of the Value added (% of GDP) in Colombia in 2004 to that in 2006?
Your response must be concise. 1.02. What is the ratio of the Value added (% of GDP) of Portugal in 2004 to that in 2006?
Give a very brief answer. 0.98. What is the ratio of the Value added (% of GDP) of Andorra in 2005 to that in 2006?
Make the answer very short. 0.99. What is the ratio of the Value added (% of GDP) in China in 2005 to that in 2006?
Keep it short and to the point. 0.99. What is the ratio of the Value added (% of GDP) in Colombia in 2005 to that in 2006?
Offer a terse response. 1.01. What is the difference between the highest and the second highest Value added (% of GDP) of Andorra?
Give a very brief answer. 0.91. What is the difference between the highest and the second highest Value added (% of GDP) of China?
Ensure brevity in your answer.  0.22. What is the difference between the highest and the second highest Value added (% of GDP) of Colombia?
Give a very brief answer. 0.03. What is the difference between the highest and the second highest Value added (% of GDP) of Portugal?
Offer a very short reply. 0.2. What is the difference between the highest and the lowest Value added (% of GDP) in Andorra?
Ensure brevity in your answer.  2.22. What is the difference between the highest and the lowest Value added (% of GDP) of China?
Offer a very short reply. 2.48. What is the difference between the highest and the lowest Value added (% of GDP) in Colombia?
Give a very brief answer. 3.54. What is the difference between the highest and the lowest Value added (% of GDP) of Portugal?
Give a very brief answer. 4.36. 